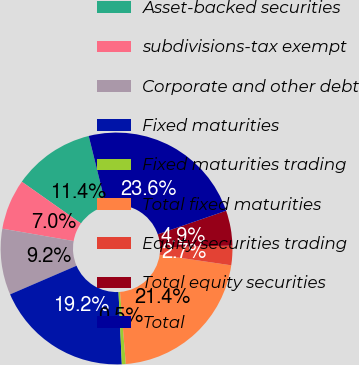Convert chart to OTSL. <chart><loc_0><loc_0><loc_500><loc_500><pie_chart><fcel>Asset-backed securities<fcel>subdivisions-tax exempt<fcel>Corporate and other debt<fcel>Fixed maturities<fcel>Fixed maturities trading<fcel>Total fixed maturities<fcel>Equity securities trading<fcel>Total equity securities<fcel>Total<nl><fcel>11.37%<fcel>7.04%<fcel>9.21%<fcel>19.25%<fcel>0.55%<fcel>21.41%<fcel>2.72%<fcel>4.88%<fcel>23.58%<nl></chart> 